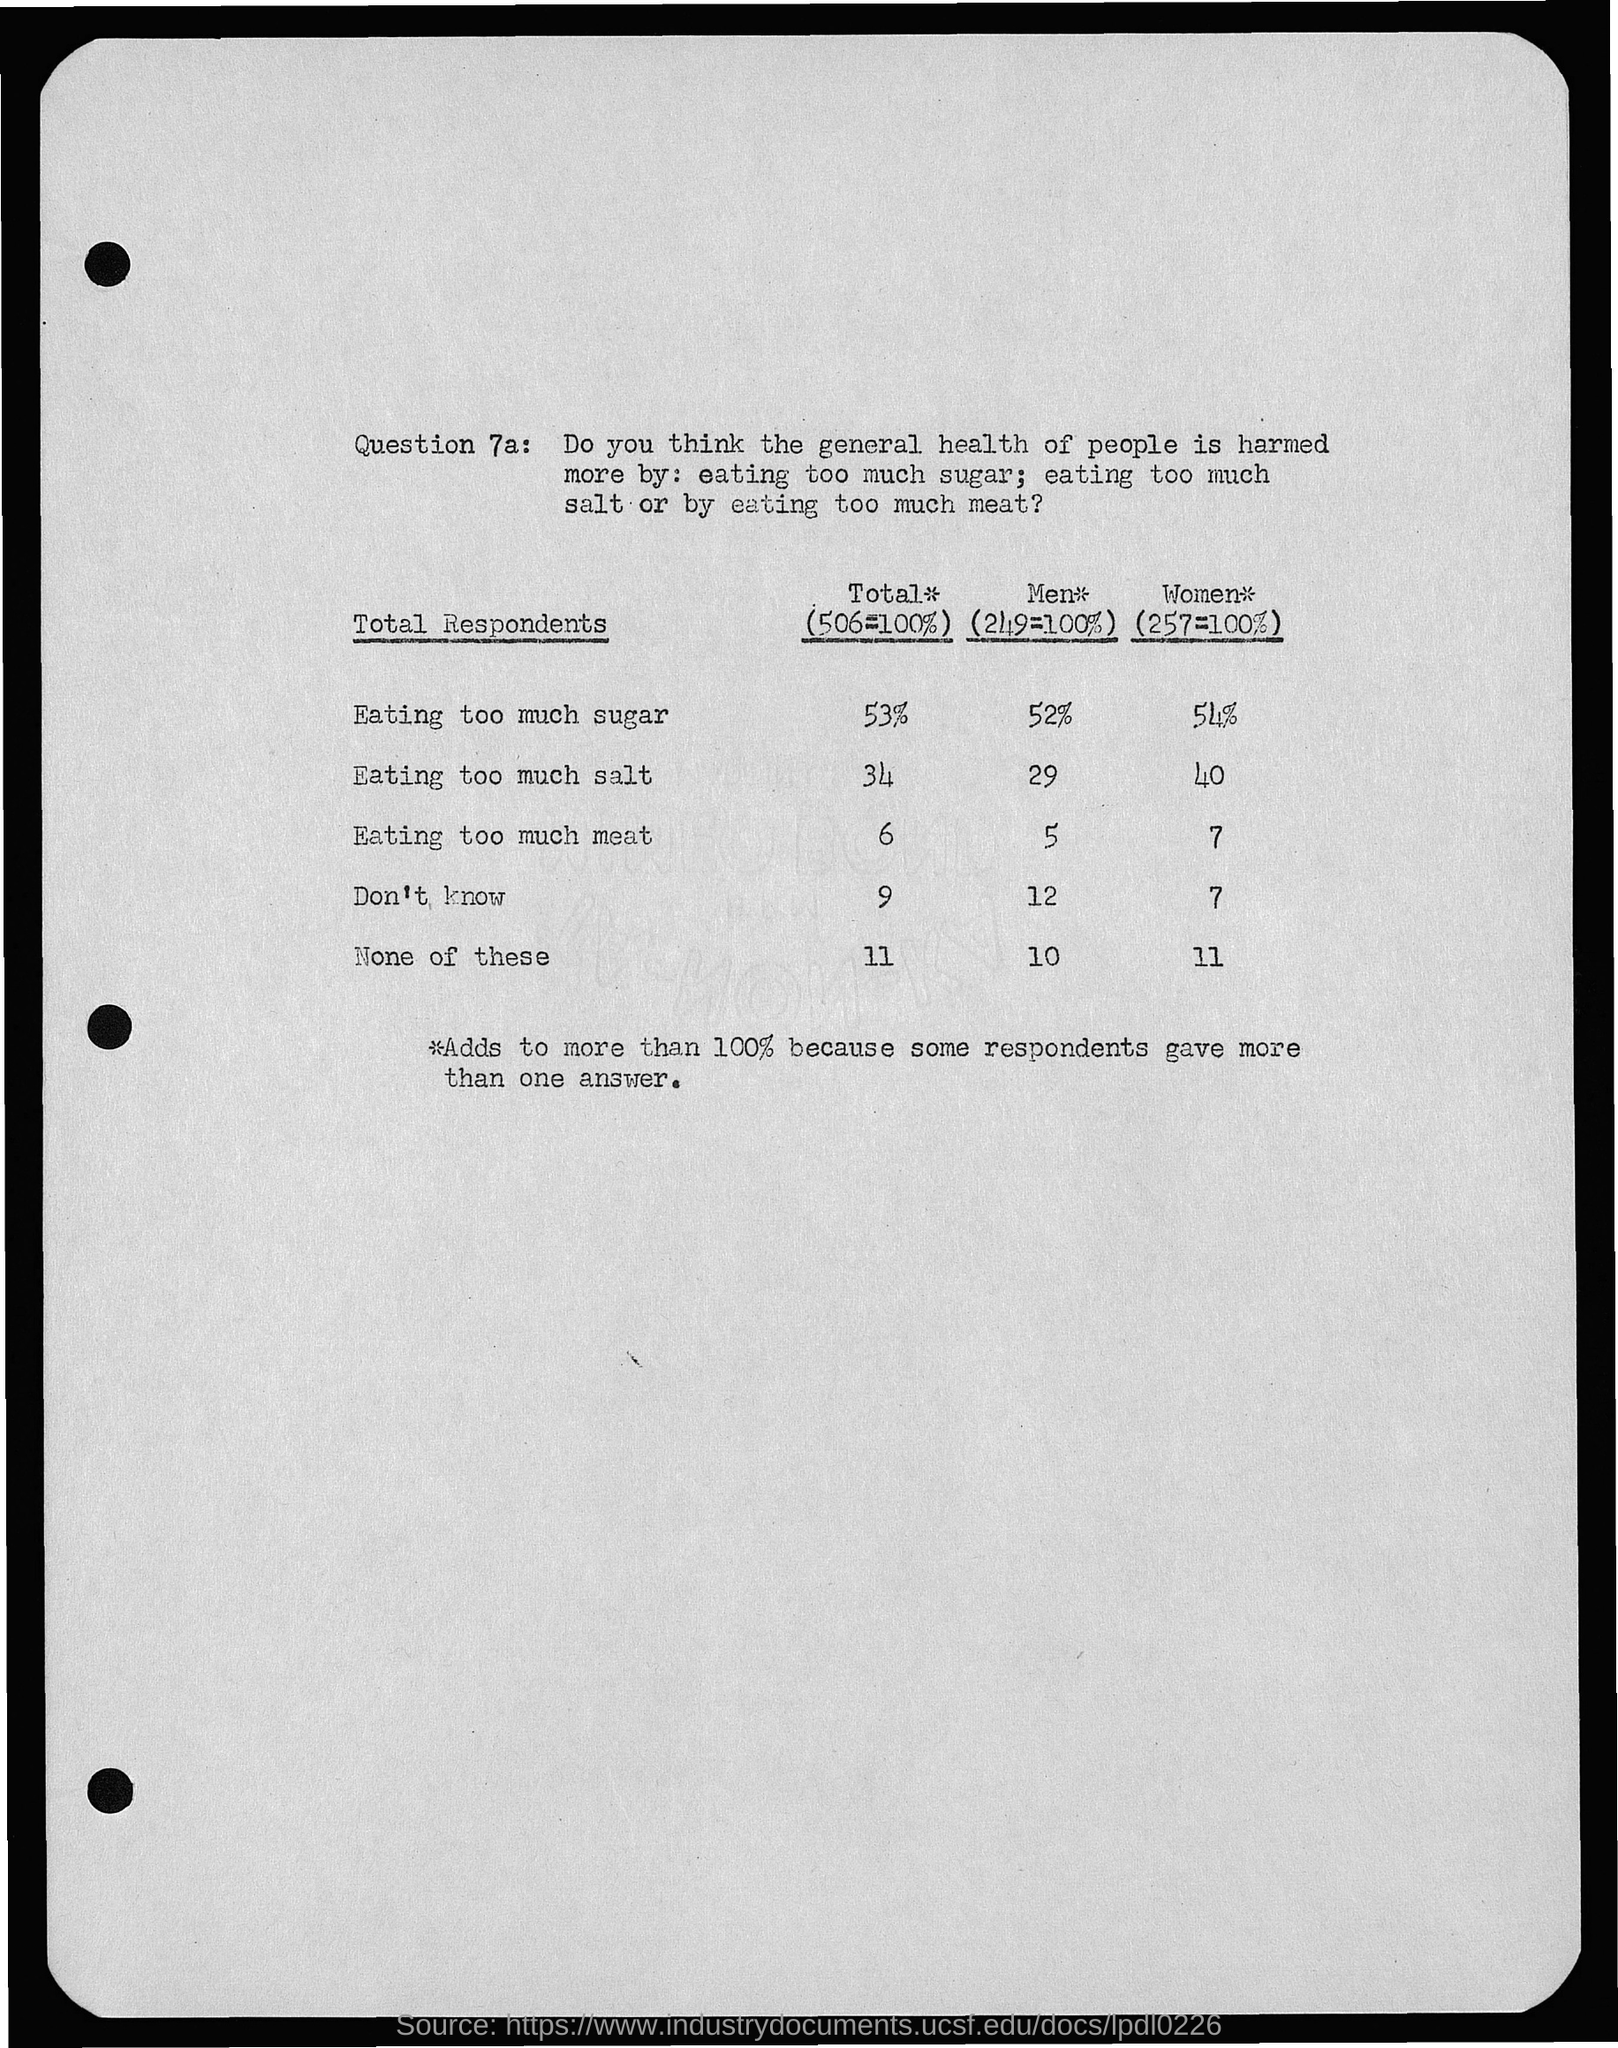What does the survey suggest is the least concerning dietary issue according to total respondents? According to the survey shown in the image, the least concerning dietary issue among the total respondents appears to be eating too much meat, with only 6% of the respondents considering it the most harmful compared to other options. 